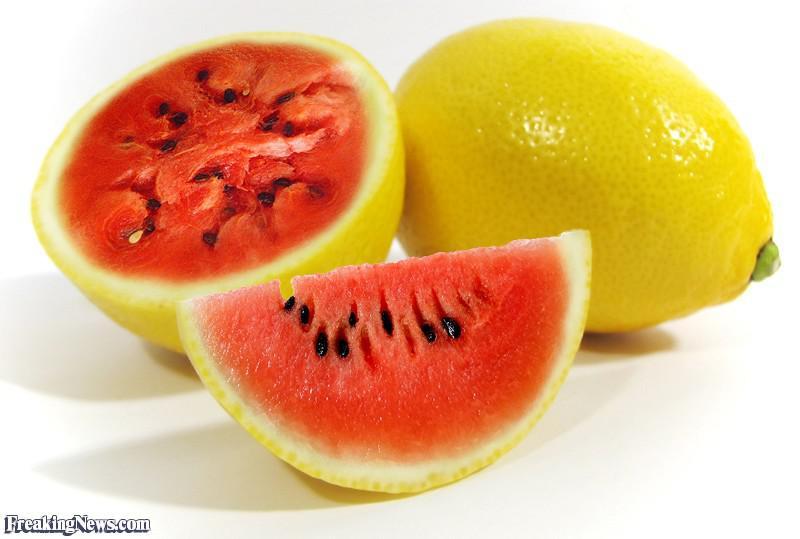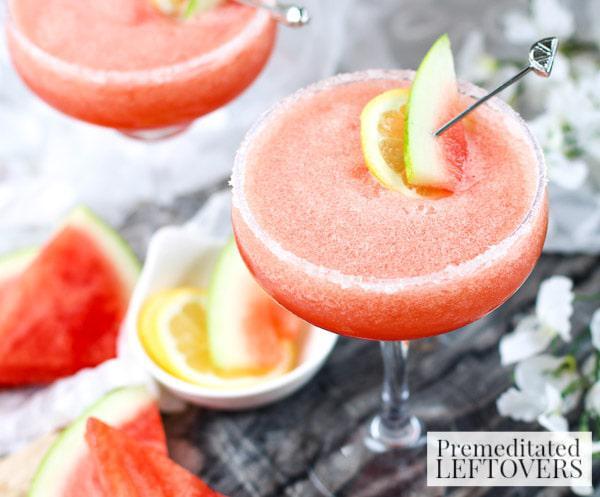The first image is the image on the left, the second image is the image on the right. For the images shown, is this caption "There is exactly one full lemon in the image on the right." true? Answer yes or no. No. 